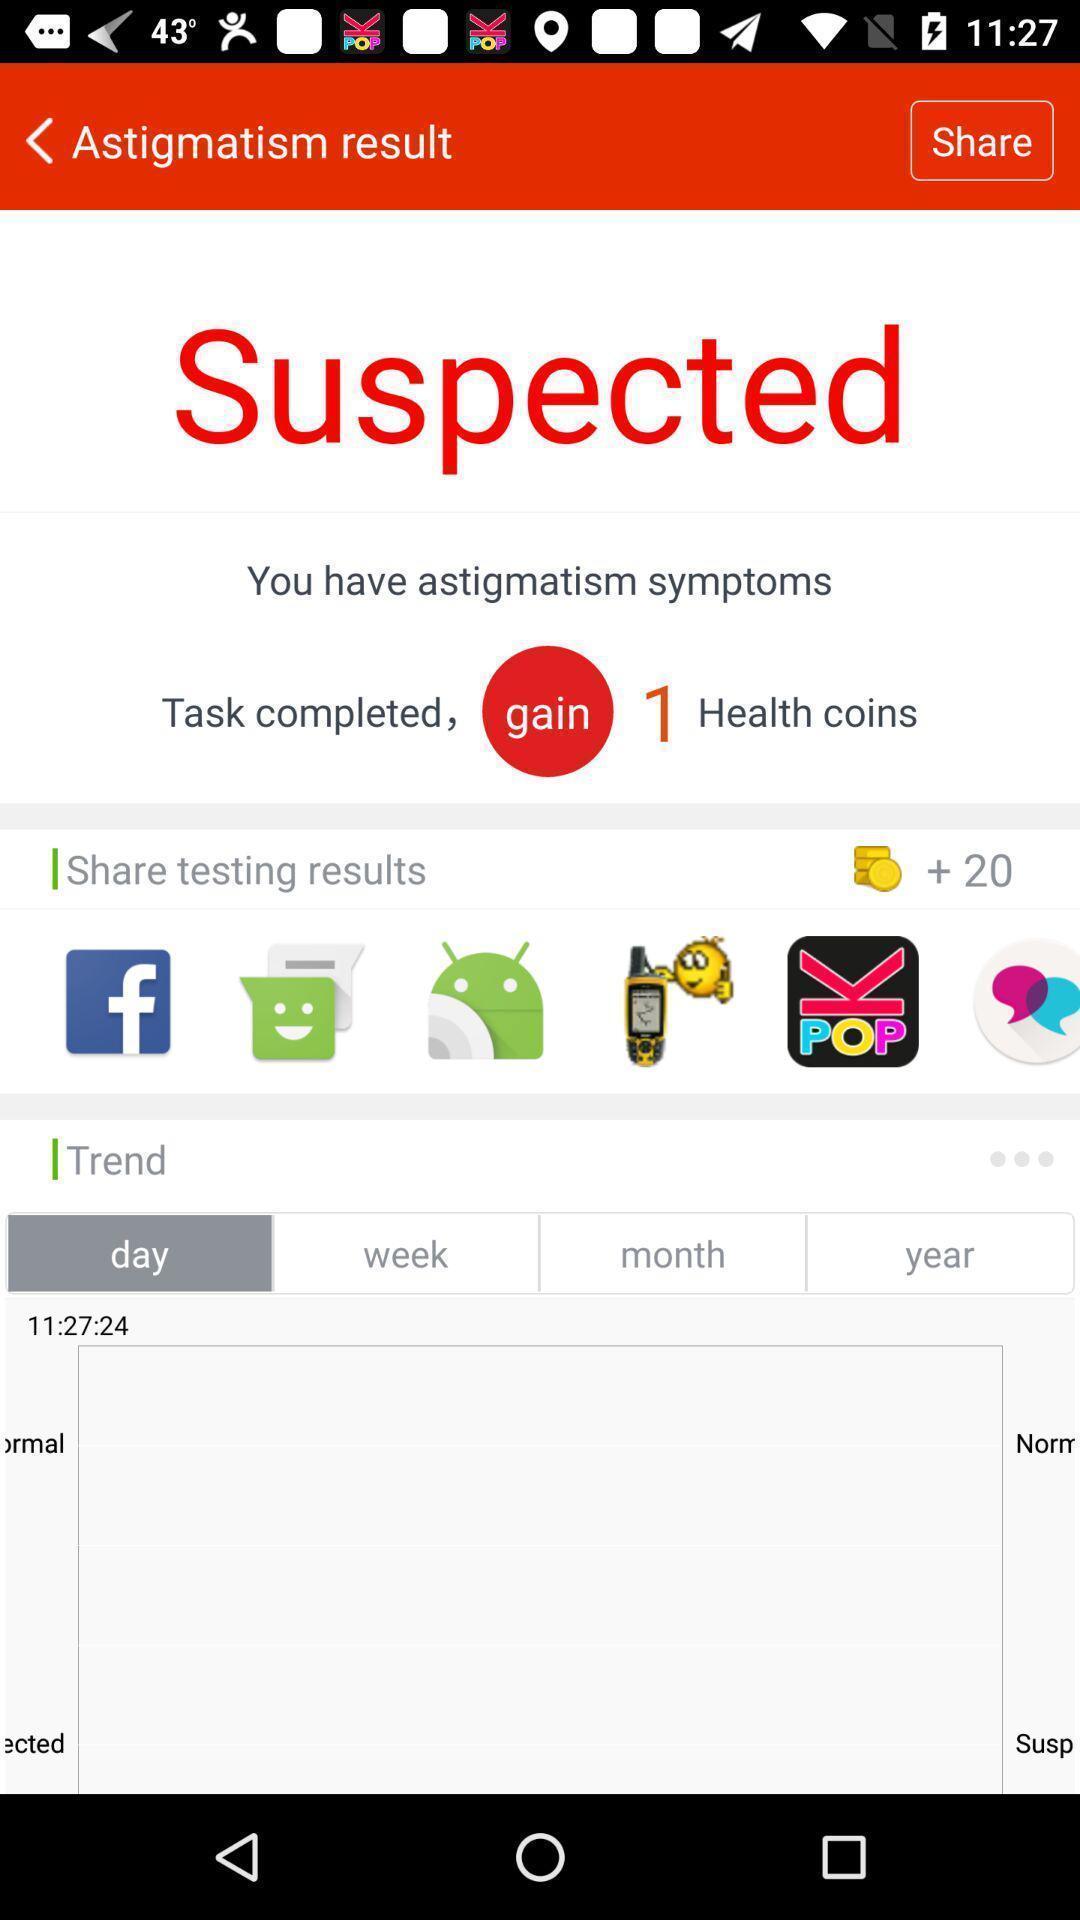Explain what's happening in this screen capture. Result page of a searched symptoms in a healthcare application. 